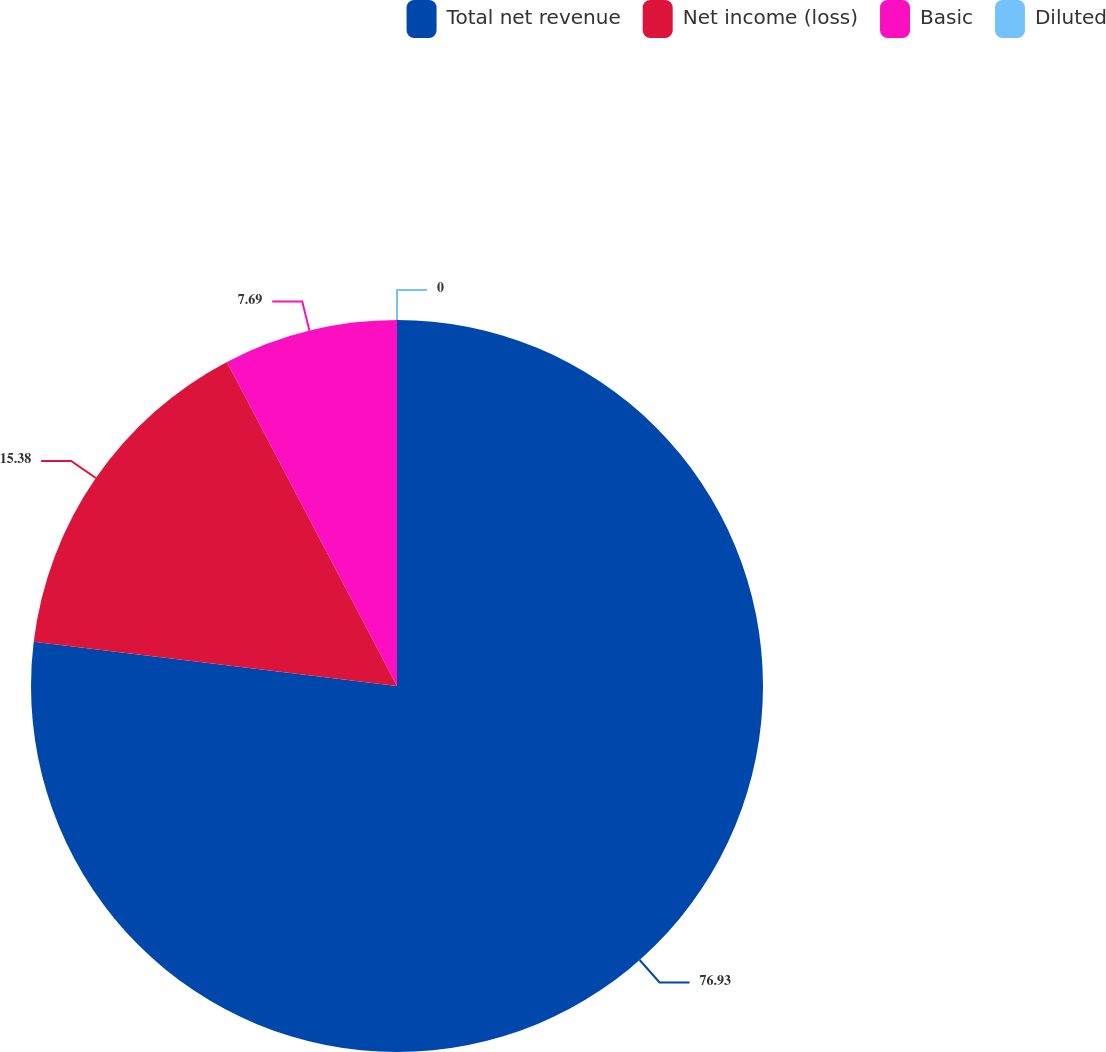Convert chart. <chart><loc_0><loc_0><loc_500><loc_500><pie_chart><fcel>Total net revenue<fcel>Net income (loss)<fcel>Basic<fcel>Diluted<nl><fcel>76.92%<fcel>15.38%<fcel>7.69%<fcel>0.0%<nl></chart> 